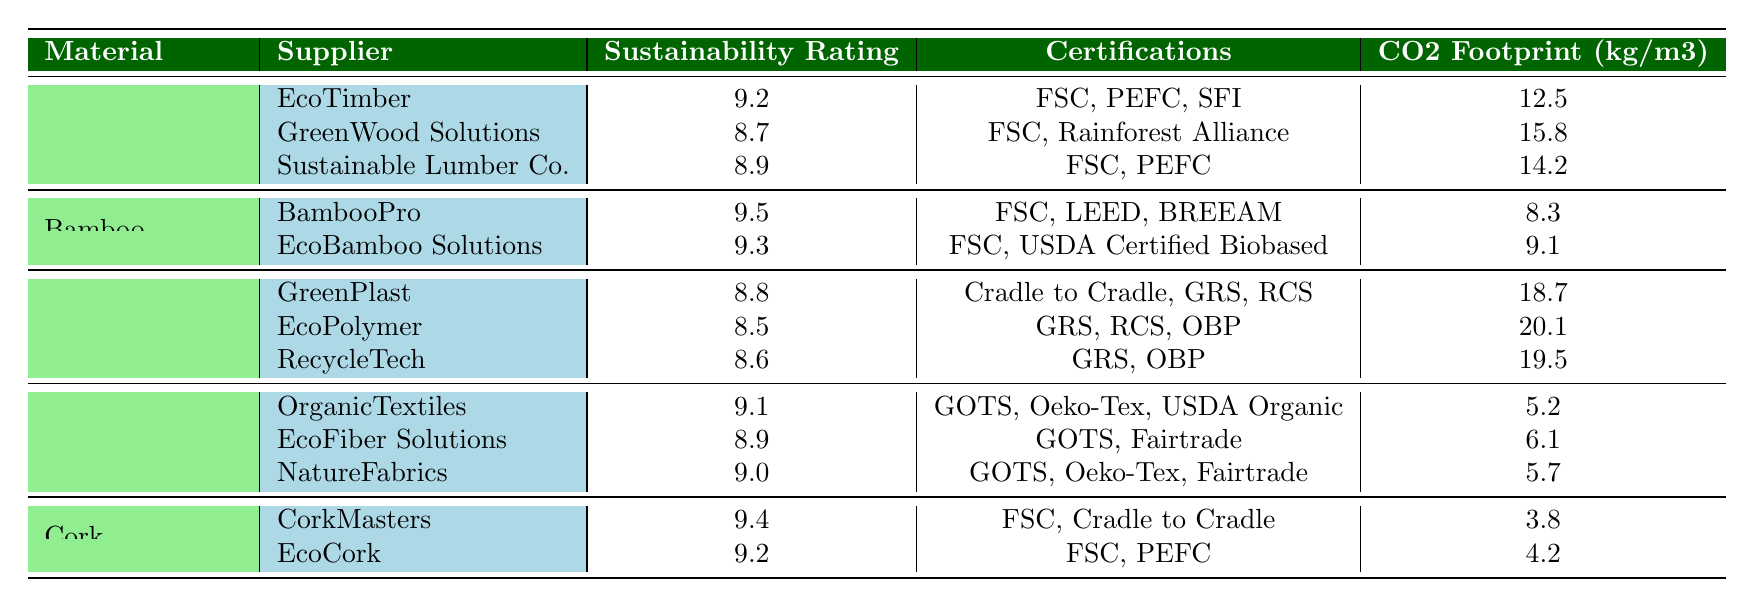What is the sustainability rating of EcoTimber? EcoTimber is listed under the Wood category in the table, and its sustainability rating is explicitly stated as 9.2.
Answer: 9.2 Which supplier has the lowest CO2 footprint in the Cork category? Looking at the Cork category, CorkMasters has a CO2 footprint of 3.8 kg/m3 and EcoCork has 4.2 kg/m3. Comparing these values, CorkMasters has the lowest.
Answer: CorkMasters What is the average sustainability rating of suppliers in the Natural Fibers category? The sustainability ratings of suppliers in the Natural Fibers category are 9.1, 8.9, and 9.0. To find the average, sum these ratings (9.1 + 8.9 + 9.0 = 27.0) and divide by the number of suppliers (3), resulting in 27.0 / 3 = 9.0.
Answer: 9.0 Which material category has the highest maximum sustainability rating among its suppliers? The Bamboo category has the highest sustainability rating of 9.5 from BambooPro, while the maximum for the Wood category is 9.2, Natural Fibers is 9.1, and the others are lower. Thus, Bamboo category has the highest rating.
Answer: Bamboo Are all suppliers of Recycled Plastic certified by GRS? Reviewing the certifications for the Recycled Plastic suppliers, GreenPlast and EcoPolymer are certified by GRS, but RecycleTech is not listed under GRS (it has GRS and OBP). Thus, not all suppliers are certified by GRS.
Answer: No What is the total CO2 footprint of all suppliers in the Wood category? The CO2 footprints for the suppliers in the Wood category are 12.5, 15.8, and 14.2. Adding these together gives a total of (12.5 + 15.8 + 14.2 = 42.5 kg/m3).
Answer: 42.5 Which supplier has the highest sustainability rating and what category do they belong to? Looking through the table, the supplier with the highest sustainability rating is BambooPro with a rating of 9.5. BambooPro belongs to the Bamboo category.
Answer: BambooPro, Bamboo How many suppliers have sustainability ratings above 9.0? In the table, the suppliers with ratings above 9.0 are EcoTimber (9.2), BambooPro (9.5), EcoBamboo Solutions (9.3), OrganicTextiles (9.1), CorkMasters (9.4), and EcoCork (9.2). Counting these, there are 6 suppliers.
Answer: 6 What is the difference in sustainability ratings between the highest-rated supplier in Natural Fibers and the highest in Recycled Plastic? The highest sustainability rating in Natural Fibers is 9.1 (OrganicTextiles), while the highest in Recycled Plastic is 8.8 (GreenPlast). The difference is 9.1 - 8.8 = 0.3.
Answer: 0.3 Which certifications are common between EcoTimber and Sustainable Lumber Co.? Both EcoTimber and Sustainable Lumber Co. list FSC as a shared certification. Examining their certifications, EcoTimber has FSC, PEFC, SFI, and Sustainable Lumber Co. has FSC, PEFC. The common certification is FSC.
Answer: FSC 